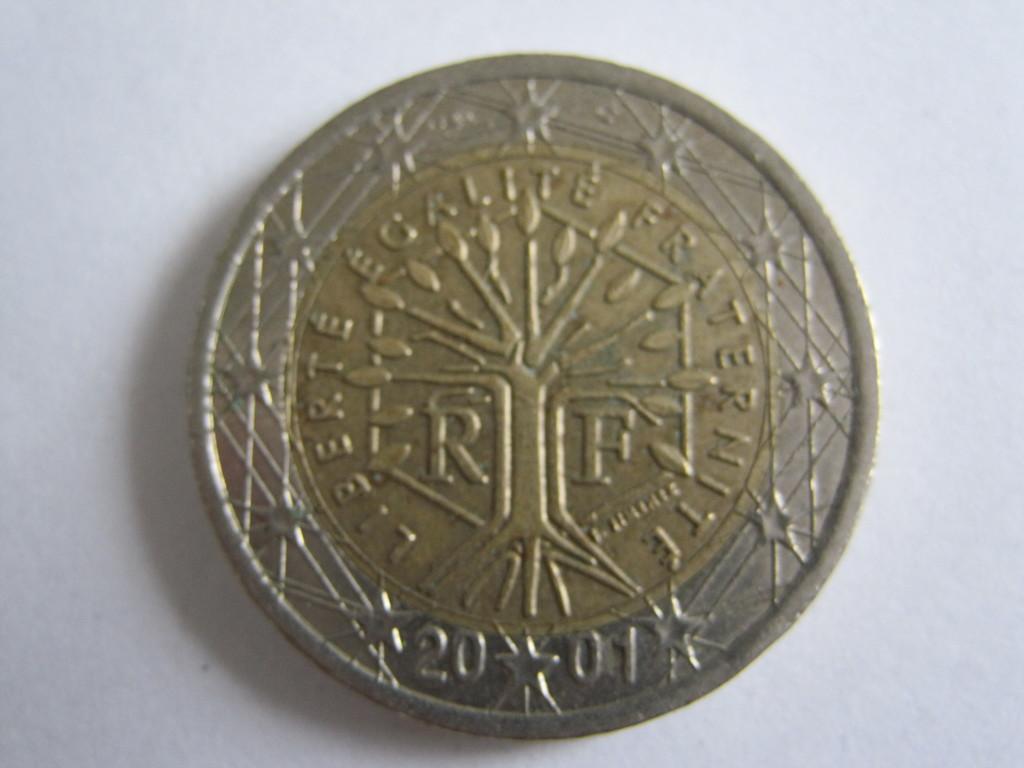What is the year on the coin?
Give a very brief answer. 2001. What letter is to the right side of the symbol?
Provide a short and direct response. F. 